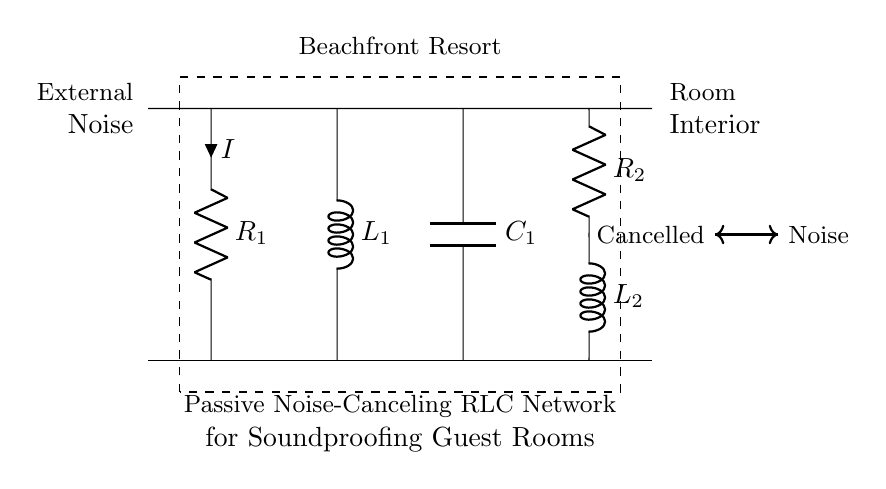What is the purpose of the circuit? The circuit is designed for passive noise-canceling, which aims to reduce external noise in guest rooms. This is evident from the labeling indicating "Passive Noise-Canceling RLC Network" and the surrounding context of a beachfront resort.
Answer: Passive noise-canceling How many resistors are in the circuit? There are two resistors present in the circuit, labeled as R1 and R2, which are indicated in the diagram.
Answer: Two What is connected to the capacitor? The capacitor, labeled as C1, is connected in series with an inductor (L1) and in parallel with two resistors. This arrangement is clearly shown in the circuit layout.
Answer: Inductor What do the arrows in the diagram represent? The arrows indicate the direction of current flow and the noise propagation path through the circuit. The one labeled "Noise" signifies the incoming noise, while "Cancelled" shows the effect of noise cancellation.
Answer: Current flow What is the relationship of the components in this circuit type? In RLC circuits, resistors dissipate energy, inductors store energy in a magnetic field, and capacitors store energy in an electric field. This interplay is critical for passive noise-canceling functionality, optimizing the circuit to manage sound waves.
Answer: Energy storage and dissipation 